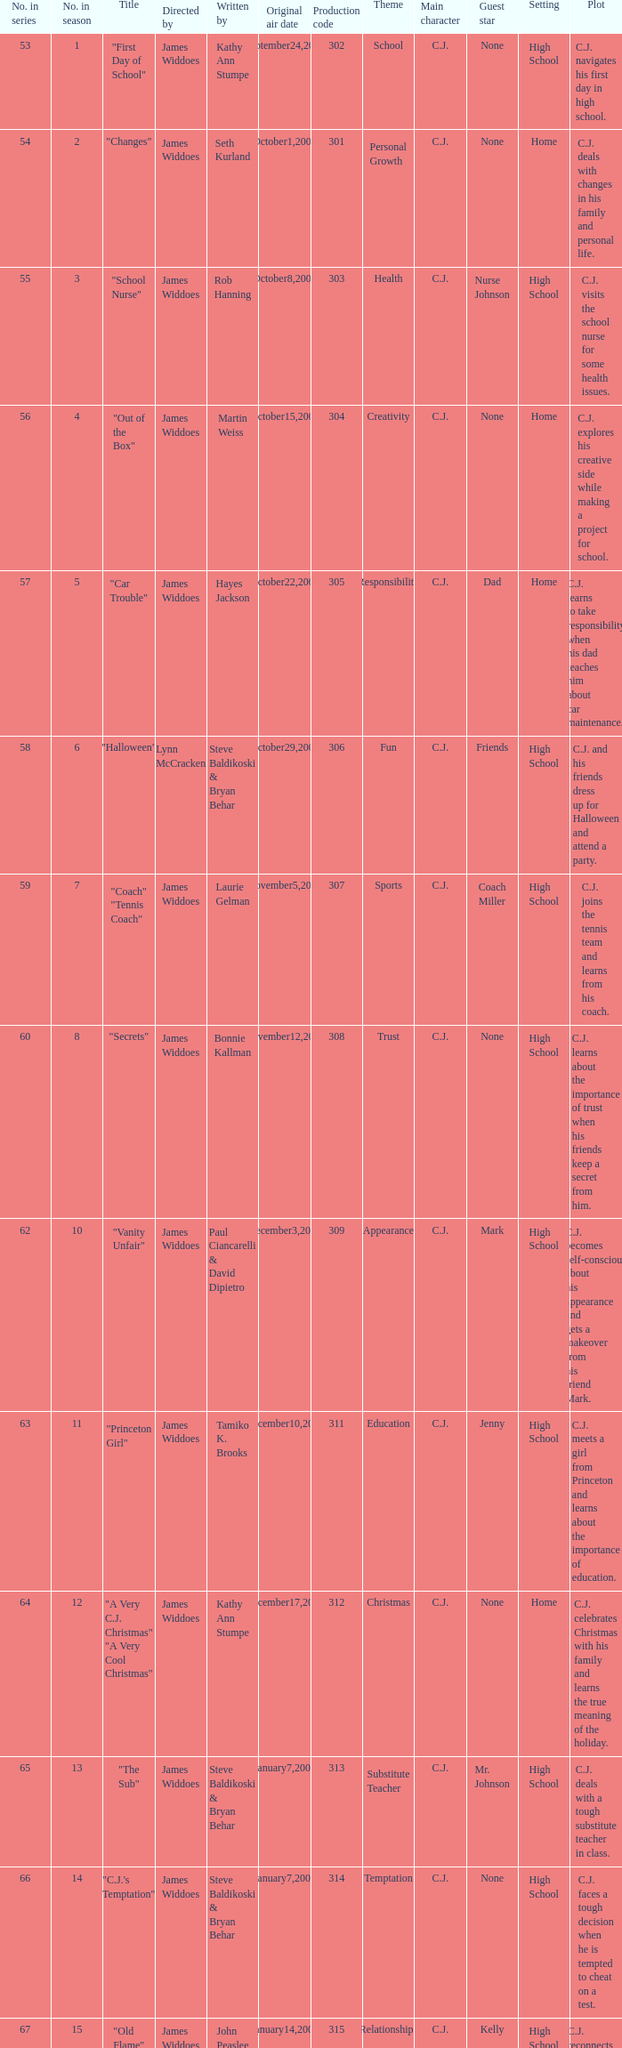How many production codes are there for "the sub"? 1.0. 